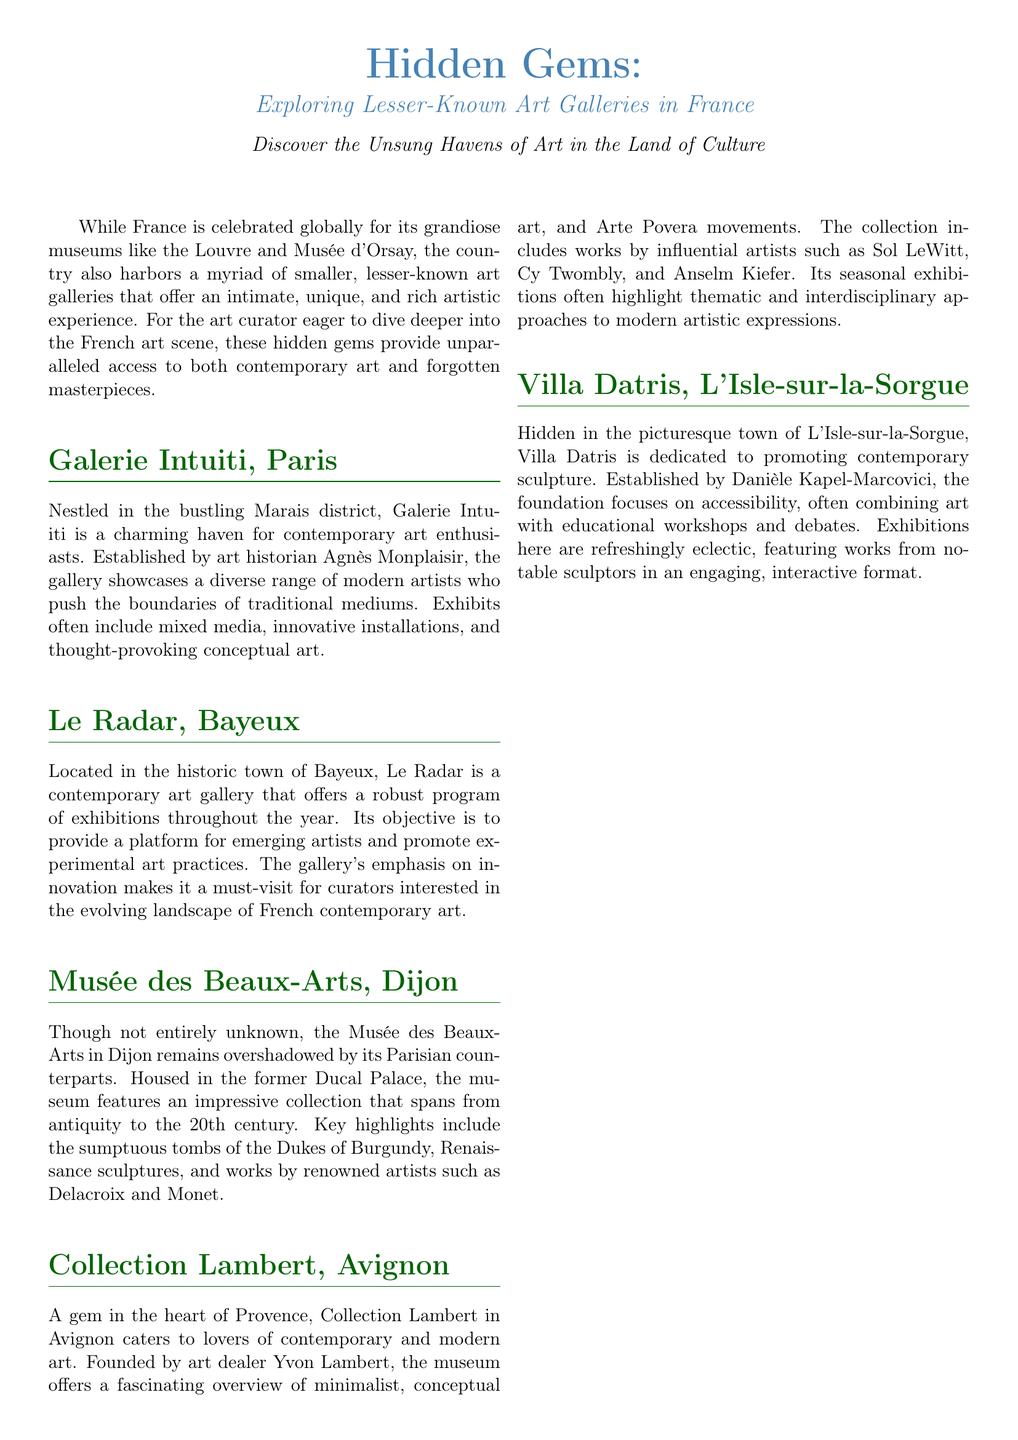What is the title of the document? The title is prominently displayed at the top of the document and describes the focus on lesser-known art galleries in France.
Answer: Hidden Gems: Exploring Lesser-Known Art Galleries in France Who established Galerie Intuiti? The document lists Agnès Monplaisir as the founder of Galerie Intuiti in Paris.
Answer: Agnès Monplaisir Where is Le Radar located? The document specifies that Le Radar is situated in the town of Bayeux in France.
Answer: Bayeux What is the primary focus of Villa Datris? The document explains that Villa Datris dedicates itself to promoting contemporary sculpture.
Answer: Contemporary sculpture Which artist is mentioned in connection with Collection Lambert? The document lists influential artists associated with the collection, including Cy Twombly.
Answer: Cy Twombly What type of exhibitions does Le Radar emphasize? The document describes that Le Radar emphasizes innovation to promote experimental art practices.
Answer: Innovation What historical elements are featured in the Musée des Beaux-Arts, Dijon? The document highlights that the museum features sumptuous tombs of the Dukes of Burgundy.
Answer: Sumptuous tombs What is the overarching theme of the document? The document centers on exploring lesser-known art galleries providing unique artistic experiences in France.
Answer: Exploring lesser-known art galleries 